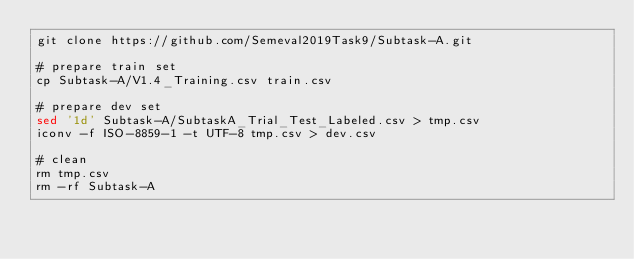<code> <loc_0><loc_0><loc_500><loc_500><_Bash_>git clone https://github.com/Semeval2019Task9/Subtask-A.git

# prepare train set
cp Subtask-A/V1.4_Training.csv train.csv

# prepare dev set
sed '1d' Subtask-A/SubtaskA_Trial_Test_Labeled.csv > tmp.csv
iconv -f ISO-8859-1 -t UTF-8 tmp.csv > dev.csv

# clean
rm tmp.csv
rm -rf Subtask-A
</code> 